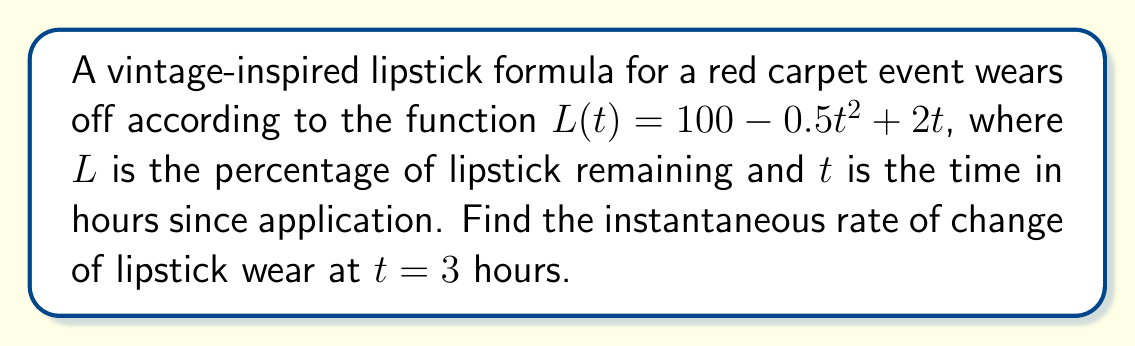Can you solve this math problem? To find the instantaneous rate of change, we need to calculate the derivative of the function $L(t)$ and then evaluate it at $t = 3$.

Step 1: Find the derivative of $L(t)$
$$L(t) = 100 - 0.5t^2 + 2t$$
$$L'(t) = -t + 2$$

Step 2: Evaluate $L'(t)$ at $t = 3$
$$L'(3) = -3 + 2 = -1$$

The negative sign indicates that the lipstick is wearing off (decreasing) at this instant.
Answer: $-1$ percent per hour 